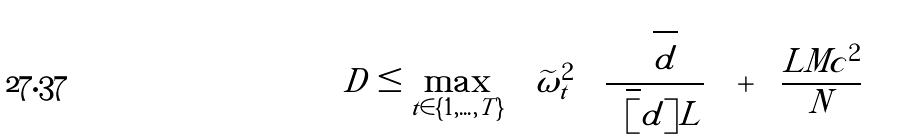Convert formula to latex. <formula><loc_0><loc_0><loc_500><loc_500>D \leq \max _ { t \in \{ 1 , \dots , T \} } \left \{ \widetilde { \omega } _ { t } ^ { 2 } \left ( \frac { \sqrt { d } } { \sqrt { [ } d ] { L } } \right ) + \left ( \frac { L M c ^ { 2 } } { N } \right ) \right \}</formula> 